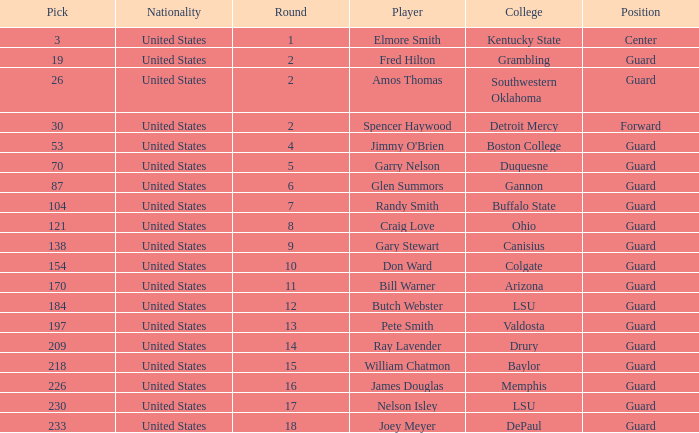WHAT IS THE NATIONALITY FOR SOUTHWESTERN OKLAHOMA? United States. 